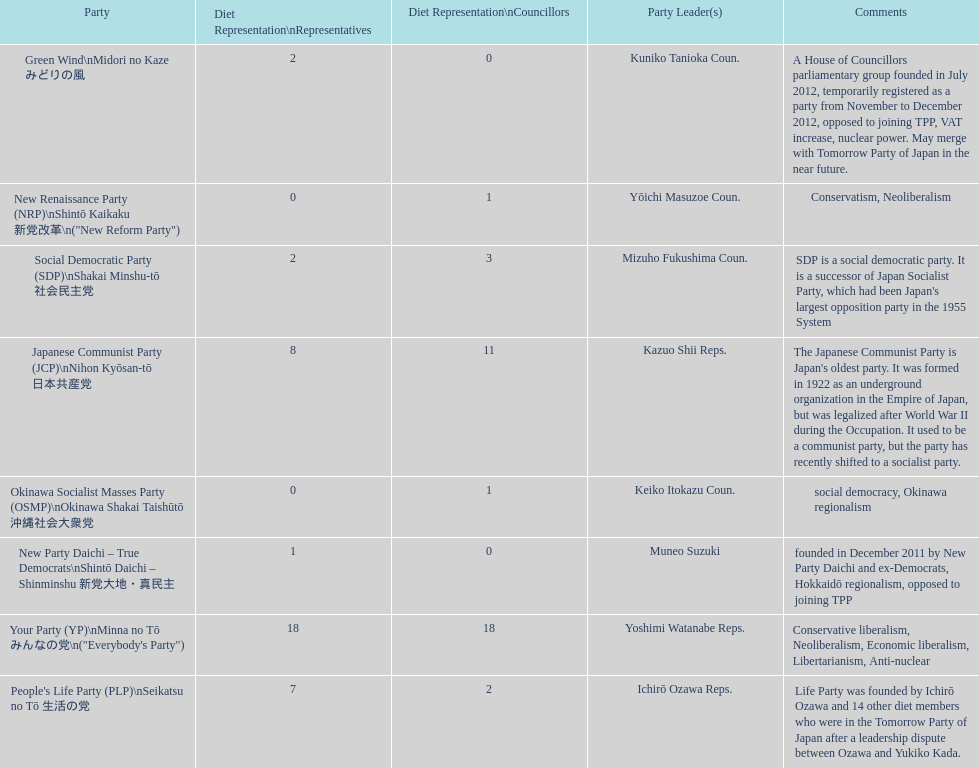According to this table, which party is japan's oldest political party? Japanese Communist Party (JCP) Nihon Kyōsan-tō 日本共産党. 